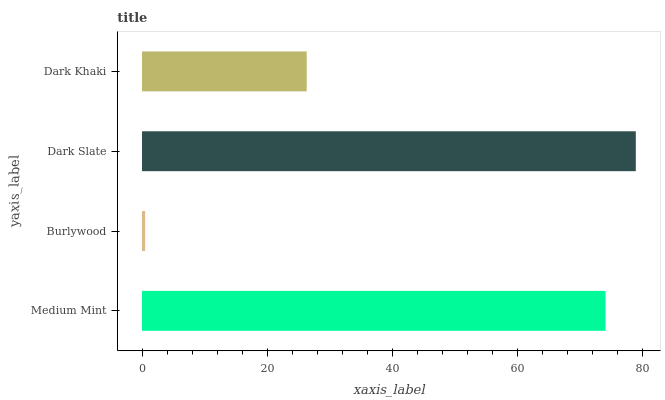Is Burlywood the minimum?
Answer yes or no. Yes. Is Dark Slate the maximum?
Answer yes or no. Yes. Is Dark Slate the minimum?
Answer yes or no. No. Is Burlywood the maximum?
Answer yes or no. No. Is Dark Slate greater than Burlywood?
Answer yes or no. Yes. Is Burlywood less than Dark Slate?
Answer yes or no. Yes. Is Burlywood greater than Dark Slate?
Answer yes or no. No. Is Dark Slate less than Burlywood?
Answer yes or no. No. Is Medium Mint the high median?
Answer yes or no. Yes. Is Dark Khaki the low median?
Answer yes or no. Yes. Is Burlywood the high median?
Answer yes or no. No. Is Medium Mint the low median?
Answer yes or no. No. 